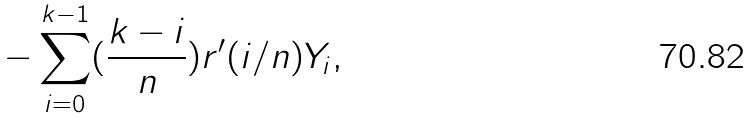Convert formula to latex. <formula><loc_0><loc_0><loc_500><loc_500>- \sum _ { i = 0 } ^ { k - 1 } ( \frac { k - i } { n } ) r ^ { \prime } ( i / n ) Y _ { i } ,</formula> 